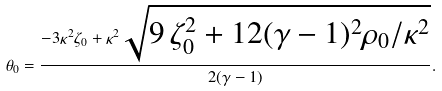Convert formula to latex. <formula><loc_0><loc_0><loc_500><loc_500>\theta _ { 0 } = \frac { - 3 \kappa ^ { 2 } \zeta _ { 0 } + \kappa ^ { 2 } \sqrt { 9 \, \zeta _ { 0 } ^ { 2 } + 1 2 ( \gamma - 1 ) ^ { 2 } \rho _ { 0 } / \kappa ^ { 2 } } } { 2 ( \gamma - 1 ) } .</formula> 